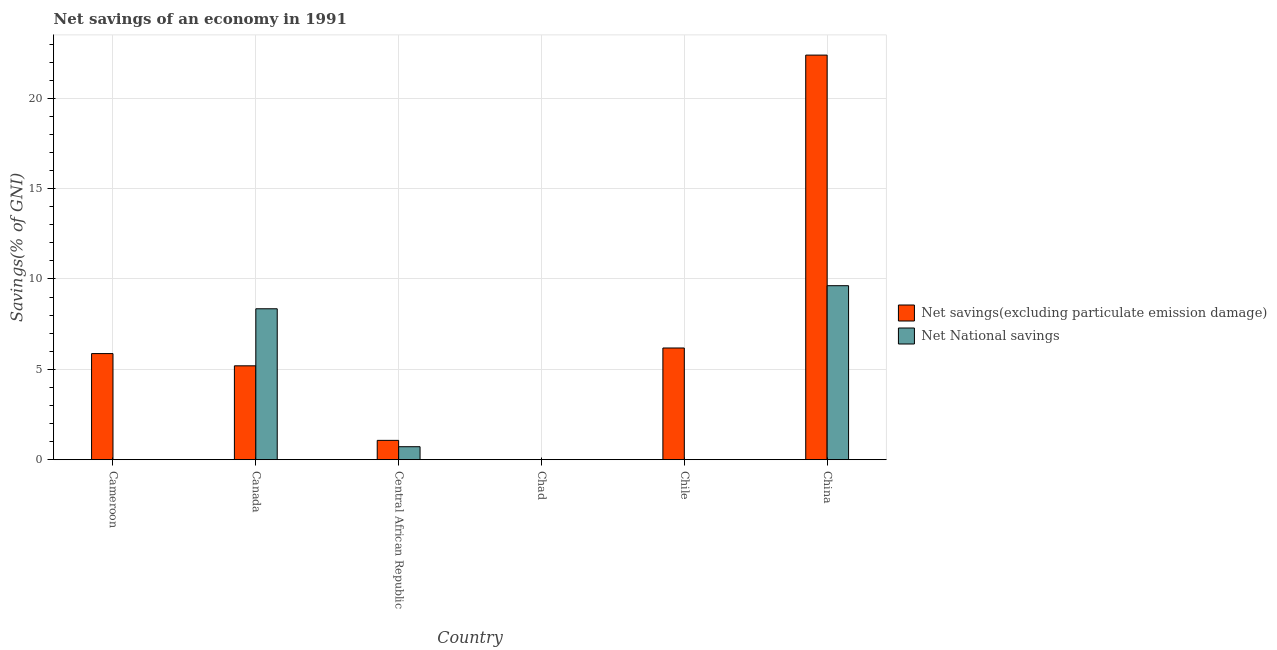Are the number of bars per tick equal to the number of legend labels?
Offer a very short reply. No. How many bars are there on the 5th tick from the left?
Give a very brief answer. 1. What is the label of the 5th group of bars from the left?
Offer a very short reply. Chile. What is the net savings(excluding particulate emission damage) in Cameroon?
Provide a short and direct response. 5.87. Across all countries, what is the maximum net savings(excluding particulate emission damage)?
Your answer should be very brief. 22.39. Across all countries, what is the minimum net savings(excluding particulate emission damage)?
Ensure brevity in your answer.  0. What is the total net national savings in the graph?
Provide a short and direct response. 18.7. What is the difference between the net savings(excluding particulate emission damage) in Cameroon and that in Canada?
Provide a succinct answer. 0.68. What is the difference between the net national savings in Chad and the net savings(excluding particulate emission damage) in Chile?
Your answer should be compact. -6.18. What is the average net national savings per country?
Your answer should be compact. 3.12. What is the difference between the net national savings and net savings(excluding particulate emission damage) in Canada?
Keep it short and to the point. 3.16. What is the ratio of the net savings(excluding particulate emission damage) in Central African Republic to that in Chile?
Provide a succinct answer. 0.17. What is the difference between the highest and the second highest net national savings?
Ensure brevity in your answer.  1.28. What is the difference between the highest and the lowest net savings(excluding particulate emission damage)?
Keep it short and to the point. 22.39. Is the sum of the net savings(excluding particulate emission damage) in Central African Republic and Chile greater than the maximum net national savings across all countries?
Your answer should be compact. No. How many bars are there?
Ensure brevity in your answer.  8. Are all the bars in the graph horizontal?
Offer a terse response. No. What is the difference between two consecutive major ticks on the Y-axis?
Offer a very short reply. 5. Are the values on the major ticks of Y-axis written in scientific E-notation?
Make the answer very short. No. Does the graph contain any zero values?
Offer a very short reply. Yes. Where does the legend appear in the graph?
Your answer should be compact. Center right. What is the title of the graph?
Make the answer very short. Net savings of an economy in 1991. Does "Number of departures" appear as one of the legend labels in the graph?
Offer a terse response. No. What is the label or title of the X-axis?
Offer a very short reply. Country. What is the label or title of the Y-axis?
Make the answer very short. Savings(% of GNI). What is the Savings(% of GNI) of Net savings(excluding particulate emission damage) in Cameroon?
Your answer should be very brief. 5.87. What is the Savings(% of GNI) of Net National savings in Cameroon?
Provide a short and direct response. 0. What is the Savings(% of GNI) in Net savings(excluding particulate emission damage) in Canada?
Offer a terse response. 5.2. What is the Savings(% of GNI) of Net National savings in Canada?
Make the answer very short. 8.35. What is the Savings(% of GNI) of Net savings(excluding particulate emission damage) in Central African Republic?
Keep it short and to the point. 1.07. What is the Savings(% of GNI) of Net National savings in Central African Republic?
Provide a short and direct response. 0.72. What is the Savings(% of GNI) of Net savings(excluding particulate emission damage) in Chile?
Ensure brevity in your answer.  6.18. What is the Savings(% of GNI) in Net savings(excluding particulate emission damage) in China?
Offer a terse response. 22.39. What is the Savings(% of GNI) of Net National savings in China?
Give a very brief answer. 9.63. Across all countries, what is the maximum Savings(% of GNI) of Net savings(excluding particulate emission damage)?
Provide a short and direct response. 22.39. Across all countries, what is the maximum Savings(% of GNI) in Net National savings?
Make the answer very short. 9.63. What is the total Savings(% of GNI) in Net savings(excluding particulate emission damage) in the graph?
Ensure brevity in your answer.  40.71. What is the total Savings(% of GNI) in Net National savings in the graph?
Keep it short and to the point. 18.7. What is the difference between the Savings(% of GNI) of Net savings(excluding particulate emission damage) in Cameroon and that in Canada?
Ensure brevity in your answer.  0.68. What is the difference between the Savings(% of GNI) of Net savings(excluding particulate emission damage) in Cameroon and that in Central African Republic?
Provide a short and direct response. 4.8. What is the difference between the Savings(% of GNI) in Net savings(excluding particulate emission damage) in Cameroon and that in Chile?
Your answer should be compact. -0.31. What is the difference between the Savings(% of GNI) in Net savings(excluding particulate emission damage) in Cameroon and that in China?
Your answer should be very brief. -16.52. What is the difference between the Savings(% of GNI) in Net savings(excluding particulate emission damage) in Canada and that in Central African Republic?
Your answer should be very brief. 4.13. What is the difference between the Savings(% of GNI) of Net National savings in Canada and that in Central African Republic?
Give a very brief answer. 7.63. What is the difference between the Savings(% of GNI) in Net savings(excluding particulate emission damage) in Canada and that in Chile?
Keep it short and to the point. -0.99. What is the difference between the Savings(% of GNI) in Net savings(excluding particulate emission damage) in Canada and that in China?
Provide a short and direct response. -17.19. What is the difference between the Savings(% of GNI) of Net National savings in Canada and that in China?
Offer a terse response. -1.28. What is the difference between the Savings(% of GNI) in Net savings(excluding particulate emission damage) in Central African Republic and that in Chile?
Your answer should be very brief. -5.11. What is the difference between the Savings(% of GNI) of Net savings(excluding particulate emission damage) in Central African Republic and that in China?
Provide a succinct answer. -21.32. What is the difference between the Savings(% of GNI) of Net National savings in Central African Republic and that in China?
Offer a very short reply. -8.91. What is the difference between the Savings(% of GNI) in Net savings(excluding particulate emission damage) in Chile and that in China?
Make the answer very short. -16.21. What is the difference between the Savings(% of GNI) of Net savings(excluding particulate emission damage) in Cameroon and the Savings(% of GNI) of Net National savings in Canada?
Give a very brief answer. -2.48. What is the difference between the Savings(% of GNI) in Net savings(excluding particulate emission damage) in Cameroon and the Savings(% of GNI) in Net National savings in Central African Republic?
Give a very brief answer. 5.15. What is the difference between the Savings(% of GNI) in Net savings(excluding particulate emission damage) in Cameroon and the Savings(% of GNI) in Net National savings in China?
Keep it short and to the point. -3.76. What is the difference between the Savings(% of GNI) of Net savings(excluding particulate emission damage) in Canada and the Savings(% of GNI) of Net National savings in Central African Republic?
Ensure brevity in your answer.  4.48. What is the difference between the Savings(% of GNI) of Net savings(excluding particulate emission damage) in Canada and the Savings(% of GNI) of Net National savings in China?
Provide a short and direct response. -4.43. What is the difference between the Savings(% of GNI) of Net savings(excluding particulate emission damage) in Central African Republic and the Savings(% of GNI) of Net National savings in China?
Provide a succinct answer. -8.56. What is the difference between the Savings(% of GNI) of Net savings(excluding particulate emission damage) in Chile and the Savings(% of GNI) of Net National savings in China?
Keep it short and to the point. -3.45. What is the average Savings(% of GNI) in Net savings(excluding particulate emission damage) per country?
Offer a terse response. 6.78. What is the average Savings(% of GNI) in Net National savings per country?
Give a very brief answer. 3.12. What is the difference between the Savings(% of GNI) in Net savings(excluding particulate emission damage) and Savings(% of GNI) in Net National savings in Canada?
Your answer should be compact. -3.16. What is the difference between the Savings(% of GNI) in Net savings(excluding particulate emission damage) and Savings(% of GNI) in Net National savings in Central African Republic?
Keep it short and to the point. 0.35. What is the difference between the Savings(% of GNI) of Net savings(excluding particulate emission damage) and Savings(% of GNI) of Net National savings in China?
Provide a short and direct response. 12.76. What is the ratio of the Savings(% of GNI) in Net savings(excluding particulate emission damage) in Cameroon to that in Canada?
Your answer should be compact. 1.13. What is the ratio of the Savings(% of GNI) in Net savings(excluding particulate emission damage) in Cameroon to that in Central African Republic?
Provide a short and direct response. 5.49. What is the ratio of the Savings(% of GNI) in Net savings(excluding particulate emission damage) in Cameroon to that in China?
Your answer should be very brief. 0.26. What is the ratio of the Savings(% of GNI) of Net savings(excluding particulate emission damage) in Canada to that in Central African Republic?
Provide a succinct answer. 4.86. What is the ratio of the Savings(% of GNI) in Net National savings in Canada to that in Central African Republic?
Ensure brevity in your answer.  11.63. What is the ratio of the Savings(% of GNI) of Net savings(excluding particulate emission damage) in Canada to that in Chile?
Your answer should be compact. 0.84. What is the ratio of the Savings(% of GNI) of Net savings(excluding particulate emission damage) in Canada to that in China?
Provide a succinct answer. 0.23. What is the ratio of the Savings(% of GNI) of Net National savings in Canada to that in China?
Offer a terse response. 0.87. What is the ratio of the Savings(% of GNI) in Net savings(excluding particulate emission damage) in Central African Republic to that in Chile?
Ensure brevity in your answer.  0.17. What is the ratio of the Savings(% of GNI) of Net savings(excluding particulate emission damage) in Central African Republic to that in China?
Ensure brevity in your answer.  0.05. What is the ratio of the Savings(% of GNI) of Net National savings in Central African Republic to that in China?
Provide a short and direct response. 0.07. What is the ratio of the Savings(% of GNI) in Net savings(excluding particulate emission damage) in Chile to that in China?
Offer a terse response. 0.28. What is the difference between the highest and the second highest Savings(% of GNI) of Net savings(excluding particulate emission damage)?
Keep it short and to the point. 16.21. What is the difference between the highest and the second highest Savings(% of GNI) in Net National savings?
Offer a very short reply. 1.28. What is the difference between the highest and the lowest Savings(% of GNI) in Net savings(excluding particulate emission damage)?
Your answer should be very brief. 22.39. What is the difference between the highest and the lowest Savings(% of GNI) of Net National savings?
Provide a succinct answer. 9.63. 